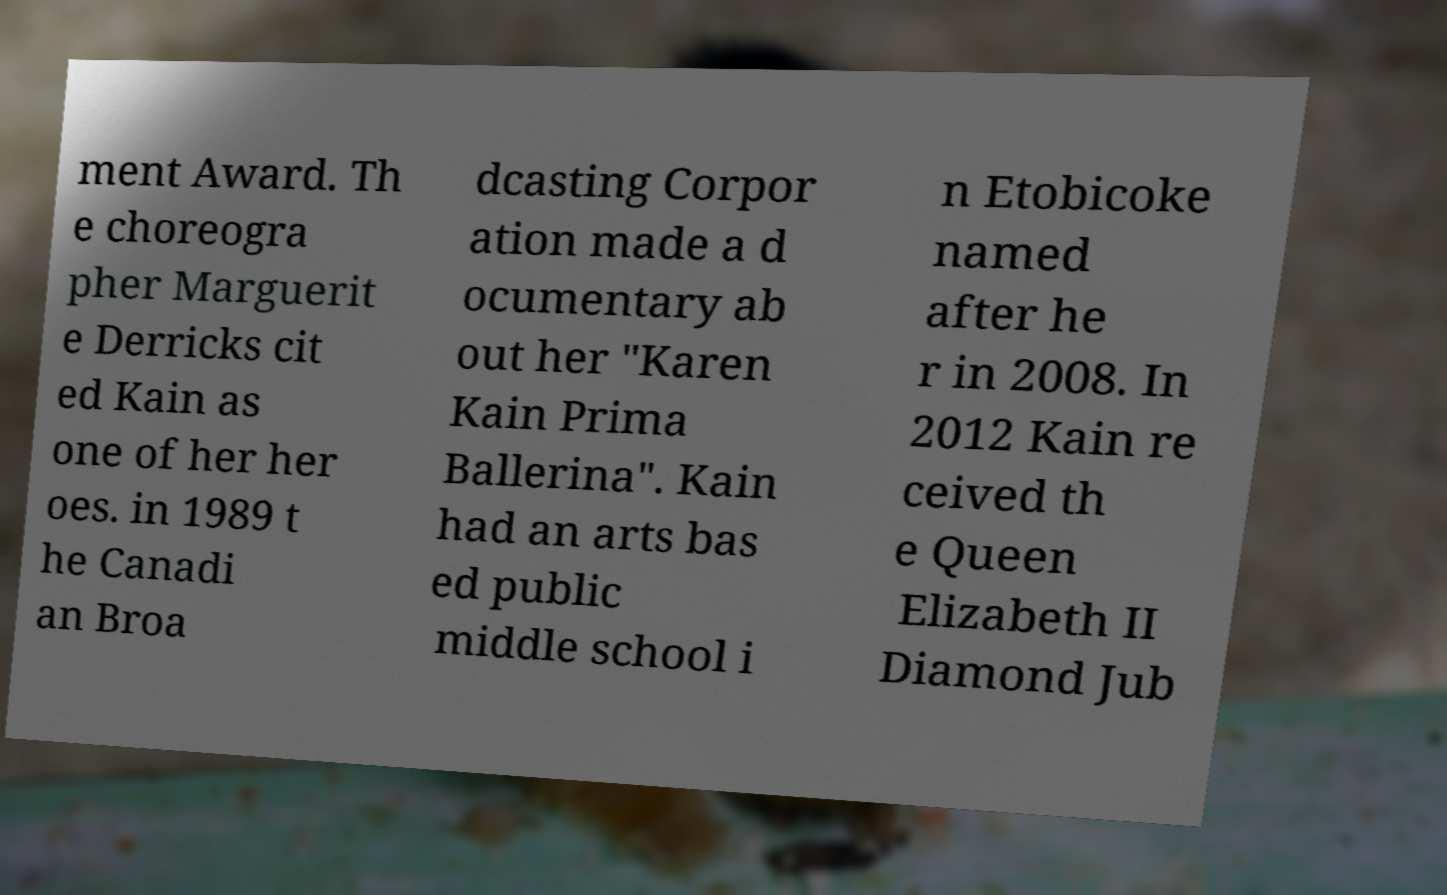What messages or text are displayed in this image? I need them in a readable, typed format. ment Award. Th e choreogra pher Marguerit e Derricks cit ed Kain as one of her her oes. in 1989 t he Canadi an Broa dcasting Corpor ation made a d ocumentary ab out her "Karen Kain Prima Ballerina". Kain had an arts bas ed public middle school i n Etobicoke named after he r in 2008. In 2012 Kain re ceived th e Queen Elizabeth II Diamond Jub 